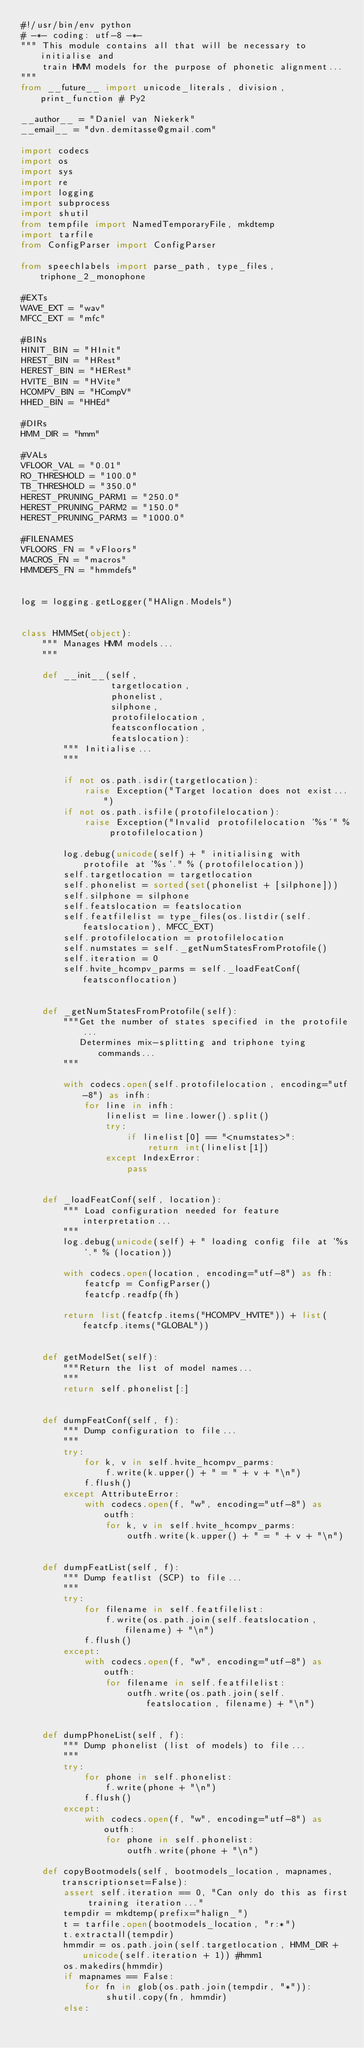Convert code to text. <code><loc_0><loc_0><loc_500><loc_500><_Python_>#!/usr/bin/env python
# -*- coding: utf-8 -*-
""" This module contains all that will be necessary to initialise and
    train HMM models for the purpose of phonetic alignment...
"""
from __future__ import unicode_literals, division, print_function # Py2

__author__ = "Daniel van Niekerk"
__email__ = "dvn.demitasse@gmail.com"

import codecs
import os
import sys
import re
import logging
import subprocess
import shutil
from tempfile import NamedTemporaryFile, mkdtemp
import tarfile
from ConfigParser import ConfigParser

from speechlabels import parse_path, type_files, triphone_2_monophone

#EXTs
WAVE_EXT = "wav"
MFCC_EXT = "mfc"

#BINs
HINIT_BIN = "HInit"
HREST_BIN = "HRest"
HEREST_BIN = "HERest"
HVITE_BIN = "HVite"
HCOMPV_BIN = "HCompV"
HHED_BIN = "HHEd"

#DIRs
HMM_DIR = "hmm"

#VALs
VFLOOR_VAL = "0.01"
RO_THRESHOLD = "100.0"
TB_THRESHOLD = "350.0"
HEREST_PRUNING_PARM1 = "250.0"
HEREST_PRUNING_PARM2 = "150.0"
HEREST_PRUNING_PARM3 = "1000.0"

#FILENAMES
VFLOORS_FN = "vFloors"
MACROS_FN = "macros"
HMMDEFS_FN = "hmmdefs"


log = logging.getLogger("HAlign.Models")


class HMMSet(object):
    """ Manages HMM models...
    """

    def __init__(self,
                 targetlocation,
                 phonelist,
                 silphone,
                 protofilelocation,
                 featsconflocation,
                 featslocation):
        """ Initialise...
        """

        if not os.path.isdir(targetlocation):
            raise Exception("Target location does not exist...")
        if not os.path.isfile(protofilelocation):
            raise Exception("Invalid protofilelocation '%s'" % protofilelocation)

        log.debug(unicode(self) + " initialising with protofile at '%s'." % (protofilelocation))
        self.targetlocation = targetlocation
        self.phonelist = sorted(set(phonelist + [silphone]))
        self.silphone = silphone
        self.featslocation = featslocation
        self.featfilelist = type_files(os.listdir(self.featslocation), MFCC_EXT)
        self.protofilelocation = protofilelocation
        self.numstates = self._getNumStatesFromProtofile()
        self.iteration = 0
        self.hvite_hcompv_parms = self._loadFeatConf(featsconflocation)


    def _getNumStatesFromProtofile(self):
        """Get the number of states specified in the protofile...
           Determines mix-splitting and triphone tying commands...
        """
        
        with codecs.open(self.protofilelocation, encoding="utf-8") as infh:
            for line in infh:
                linelist = line.lower().split()
                try:
                    if linelist[0] == "<numstates>":
                        return int(linelist[1])
                except IndexError:
                    pass    


    def _loadFeatConf(self, location):
        """ Load configuration needed for feature interpretation...
        """
        log.debug(unicode(self) + " loading config file at '%s'." % (location))

        with codecs.open(location, encoding="utf-8") as fh:
            featcfp = ConfigParser()
            featcfp.readfp(fh)

        return list(featcfp.items("HCOMPV_HVITE")) + list(featcfp.items("GLOBAL"))


    def getModelSet(self):
        """Return the list of model names...
        """
        return self.phonelist[:]


    def dumpFeatConf(self, f):
        """ Dump configuration to file...
        """
        try:
            for k, v in self.hvite_hcompv_parms:
                f.write(k.upper() + " = " + v + "\n")
            f.flush()
        except AttributeError:
            with codecs.open(f, "w", encoding="utf-8") as outfh:
                for k, v in self.hvite_hcompv_parms:
                    outfh.write(k.upper() + " = " + v + "\n")


    def dumpFeatList(self, f):
        """ Dump featlist (SCP) to file...
        """
        try:
            for filename in self.featfilelist:
                f.write(os.path.join(self.featslocation, filename) + "\n")
            f.flush()
        except:
            with codecs.open(f, "w", encoding="utf-8") as outfh:
                for filename in self.featfilelist:
                    outfh.write(os.path.join(self.featslocation, filename) + "\n")


    def dumpPhoneList(self, f):
        """ Dump phonelist (list of models) to file...
        """
        try:
            for phone in self.phonelist:
                f.write(phone + "\n")
            f.flush()
        except:
            with codecs.open(f, "w", encoding="utf-8") as outfh:
                for phone in self.phonelist:
                    outfh.write(phone + "\n")

    def copyBootmodels(self, bootmodels_location, mapnames, transcriptionset=False):
        assert self.iteration == 0, "Can only do this as first training iteration..."
        tempdir = mkdtemp(prefix="halign_")
        t = tarfile.open(bootmodels_location, "r:*")
        t.extractall(tempdir)
        hmmdir = os.path.join(self.targetlocation, HMM_DIR + unicode(self.iteration + 1)) #hmm1
        os.makedirs(hmmdir)
        if mapnames == False:
            for fn in glob(os.path.join(tempdir, "*")):
                shutil.copy(fn, hmmdir)
        else:</code> 